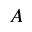<formula> <loc_0><loc_0><loc_500><loc_500>A</formula> 